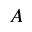<formula> <loc_0><loc_0><loc_500><loc_500>A</formula> 